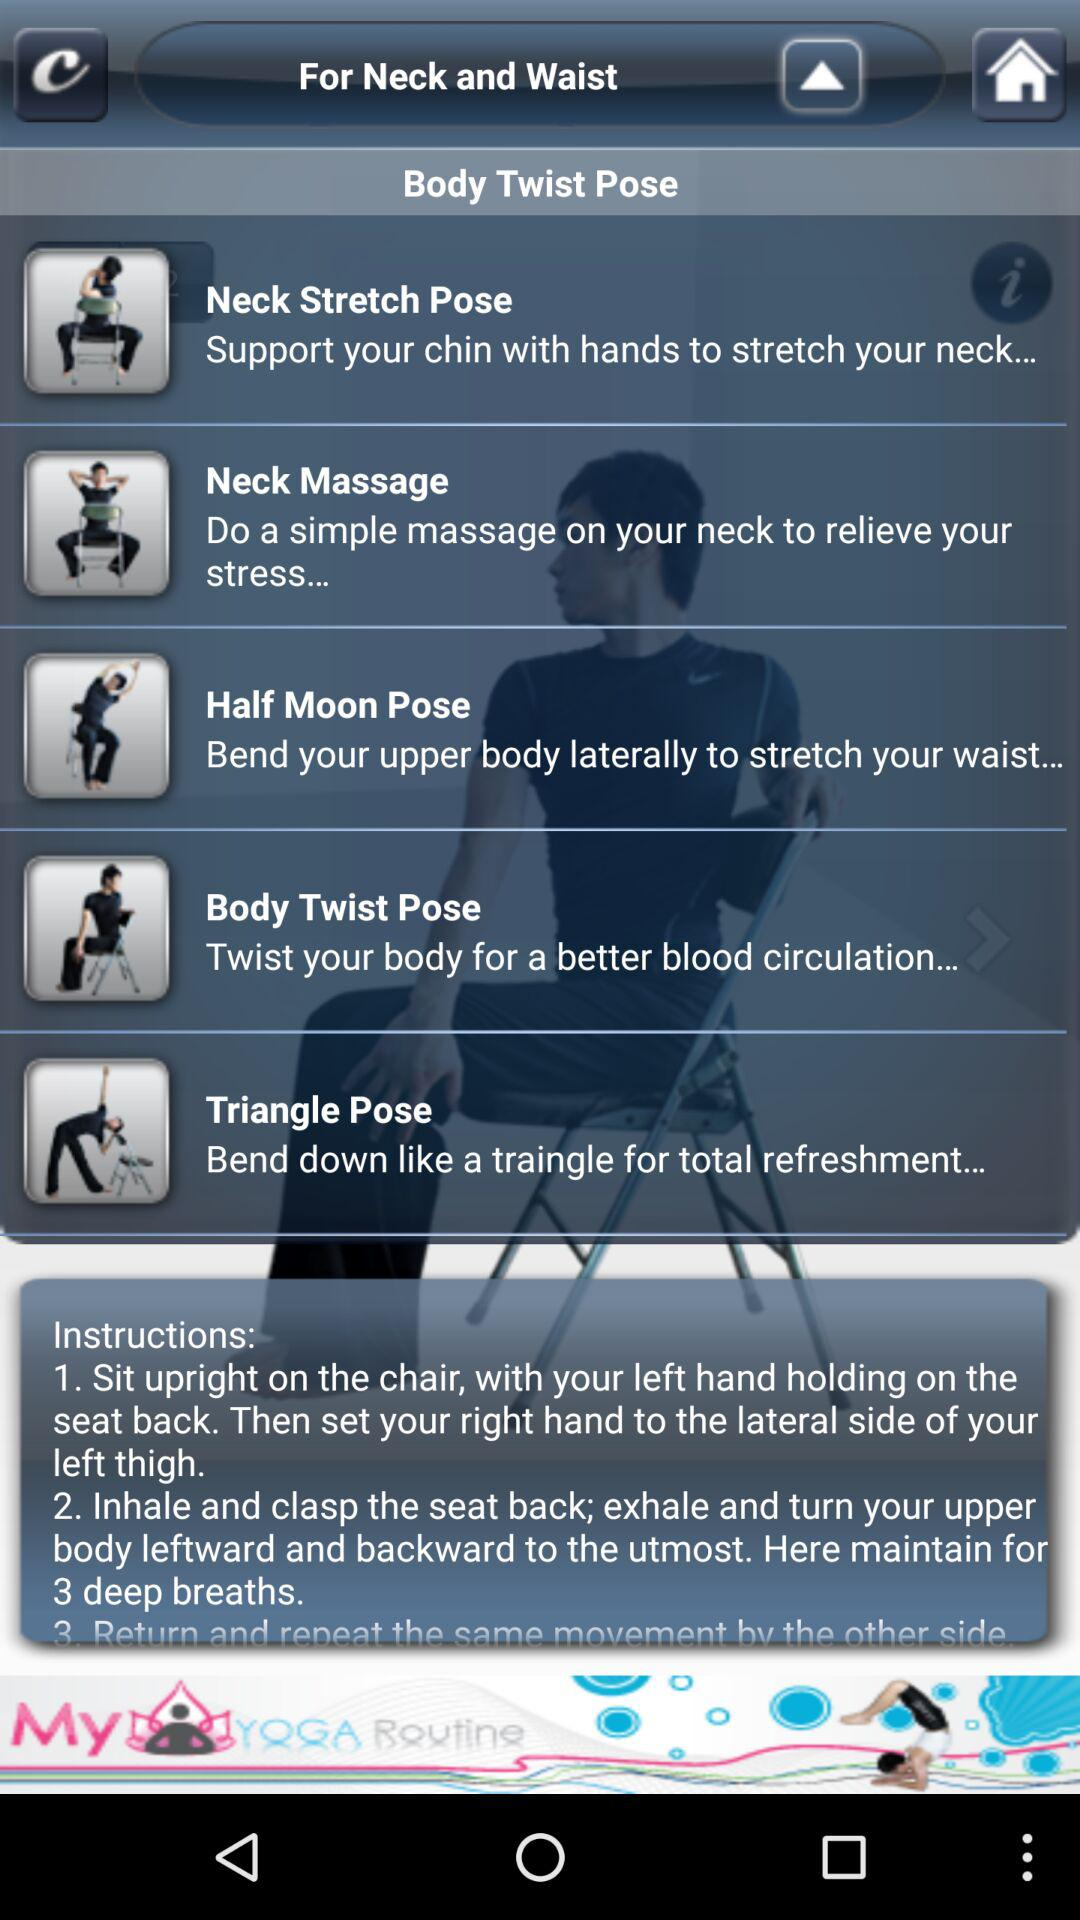How many poses are there for neck and waist?
Answer the question using a single word or phrase. 4 